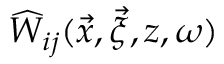Convert formula to latex. <formula><loc_0><loc_0><loc_500><loc_500>\widehat { W } _ { i j } ( \vec { x } , \vec { \xi } , z , \omega )</formula> 